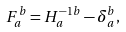Convert formula to latex. <formula><loc_0><loc_0><loc_500><loc_500>F _ { a } ^ { b } = H ^ { - 1 b } _ { a } - \delta _ { a } ^ { b } ,</formula> 